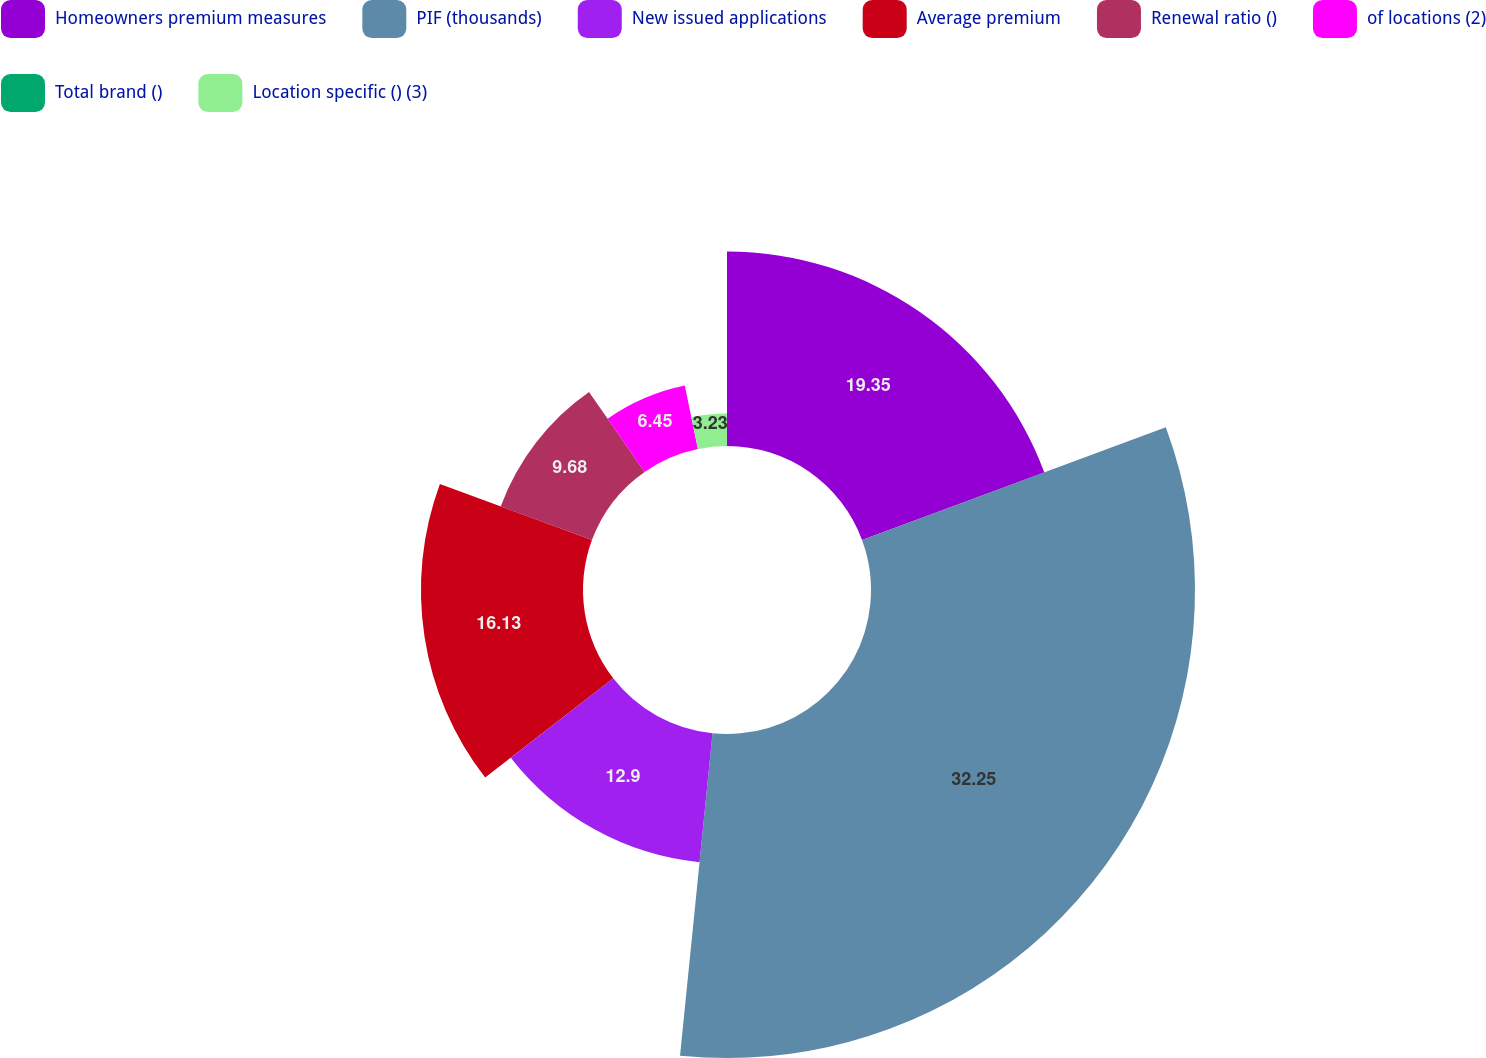Convert chart. <chart><loc_0><loc_0><loc_500><loc_500><pie_chart><fcel>Homeowners premium measures<fcel>PIF (thousands)<fcel>New issued applications<fcel>Average premium<fcel>Renewal ratio ()<fcel>of locations (2)<fcel>Total brand ()<fcel>Location specific () (3)<nl><fcel>19.35%<fcel>32.25%<fcel>12.9%<fcel>16.13%<fcel>9.68%<fcel>6.45%<fcel>0.01%<fcel>3.23%<nl></chart> 